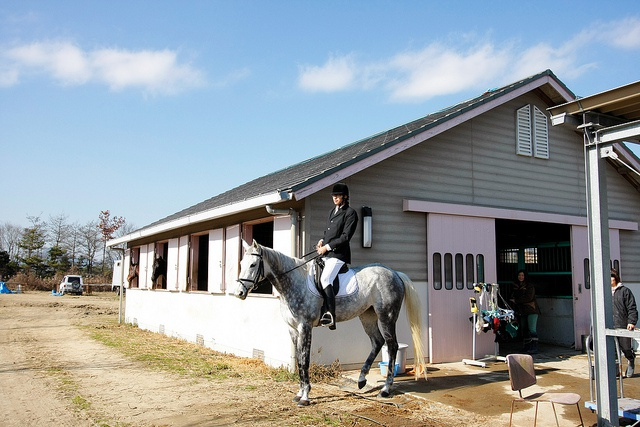Describe the objects in this image and their specific colors. I can see horse in lightblue, gray, black, white, and darkgray tones, people in lightblue, black, gray, white, and darkgray tones, people in lightblue, black, gray, darkgray, and maroon tones, chair in lightblue, black, gray, lightgray, and tan tones, and people in lightblue, black, maroon, and teal tones in this image. 